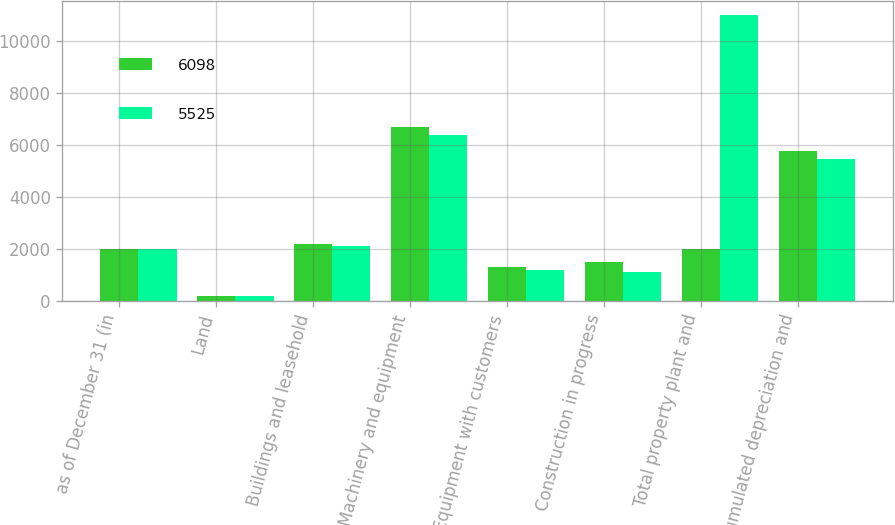Convert chart to OTSL. <chart><loc_0><loc_0><loc_500><loc_500><stacked_bar_chart><ecel><fcel>as of December 31 (in<fcel>Land<fcel>Buildings and leasehold<fcel>Machinery and equipment<fcel>Equipment with customers<fcel>Construction in progress<fcel>Total property plant and<fcel>Accumulated depreciation and<nl><fcel>6098<fcel>2012<fcel>190<fcel>2181<fcel>6691<fcel>1295<fcel>1512<fcel>2012<fcel>5771<nl><fcel>5525<fcel>2011<fcel>184<fcel>2099<fcel>6384<fcel>1205<fcel>1101<fcel>10973<fcel>5448<nl></chart> 